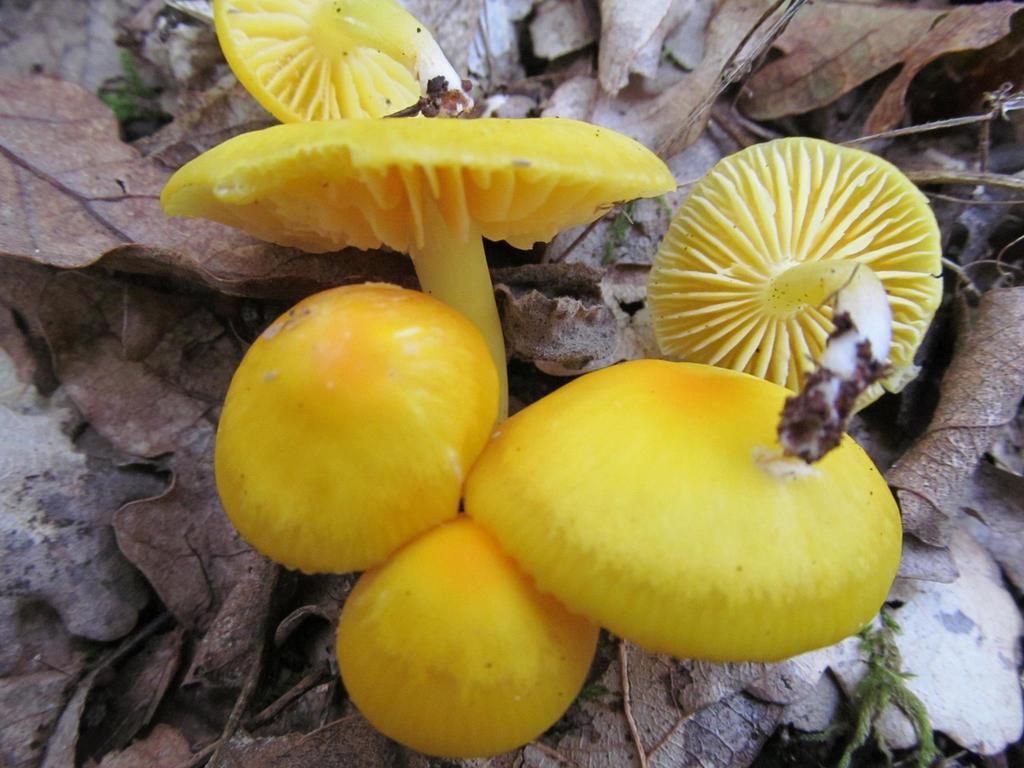How would you summarize this image in a sentence or two? In this image I can see few yellow color mushrooms and back I can see few dry leaves. 